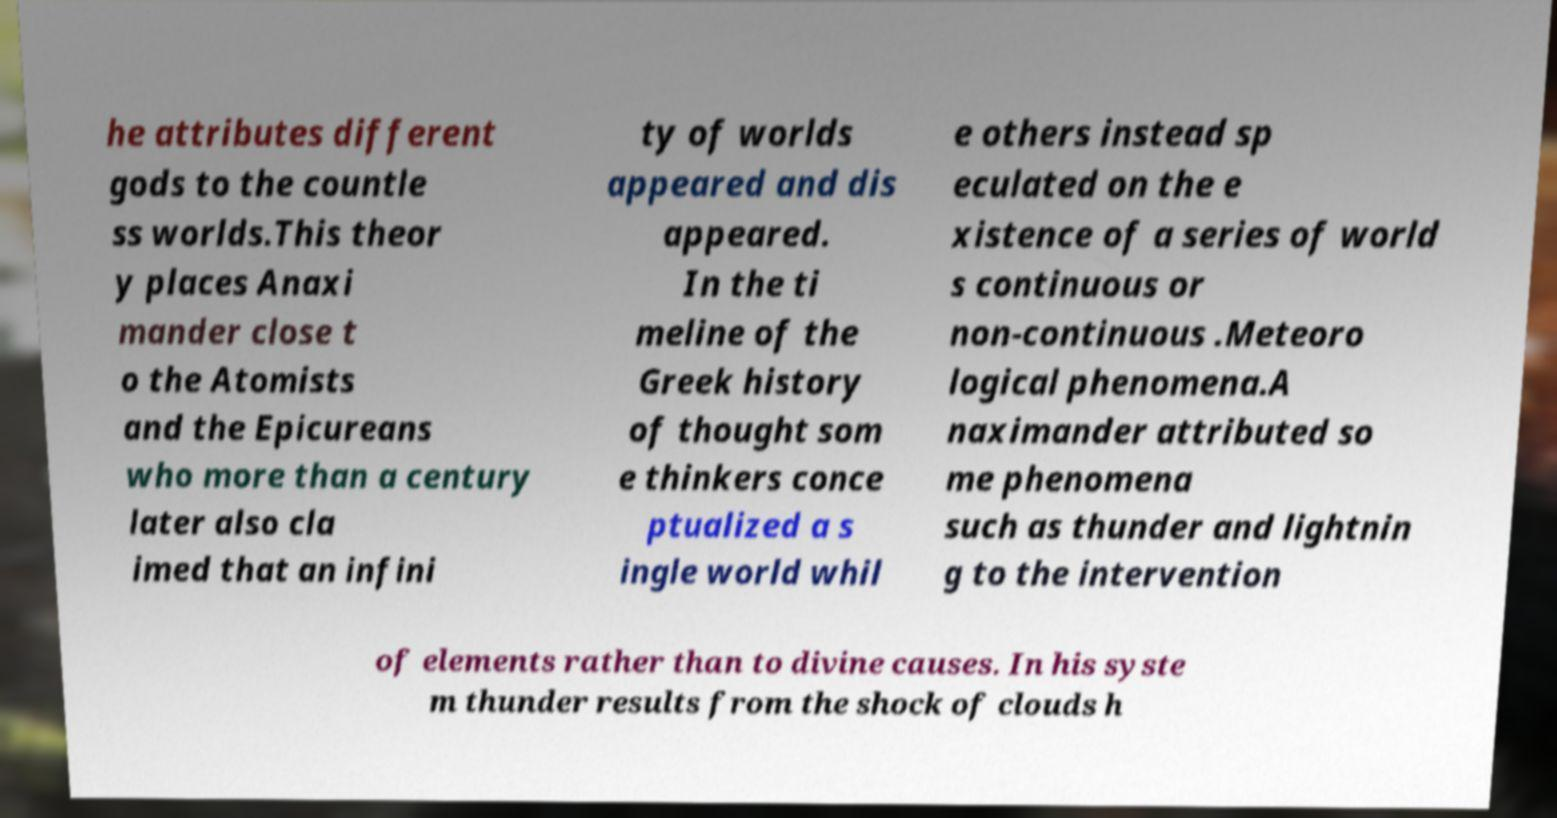Please identify and transcribe the text found in this image. he attributes different gods to the countle ss worlds.This theor y places Anaxi mander close t o the Atomists and the Epicureans who more than a century later also cla imed that an infini ty of worlds appeared and dis appeared. In the ti meline of the Greek history of thought som e thinkers conce ptualized a s ingle world whil e others instead sp eculated on the e xistence of a series of world s continuous or non-continuous .Meteoro logical phenomena.A naximander attributed so me phenomena such as thunder and lightnin g to the intervention of elements rather than to divine causes. In his syste m thunder results from the shock of clouds h 